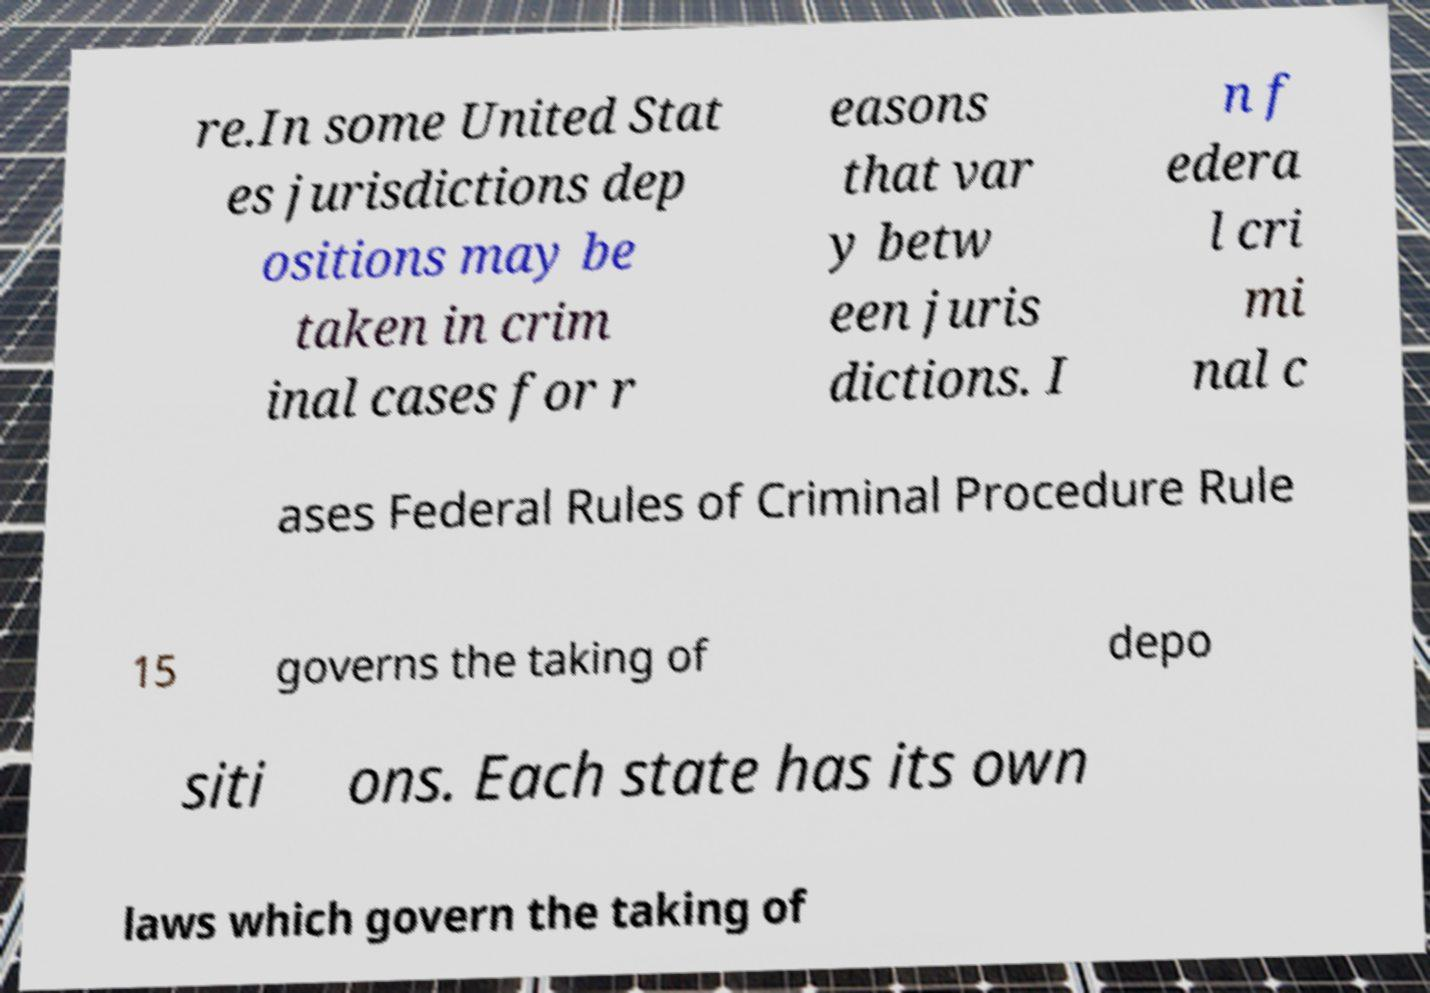Could you assist in decoding the text presented in this image and type it out clearly? re.In some United Stat es jurisdictions dep ositions may be taken in crim inal cases for r easons that var y betw een juris dictions. I n f edera l cri mi nal c ases Federal Rules of Criminal Procedure Rule 15 governs the taking of depo siti ons. Each state has its own laws which govern the taking of 